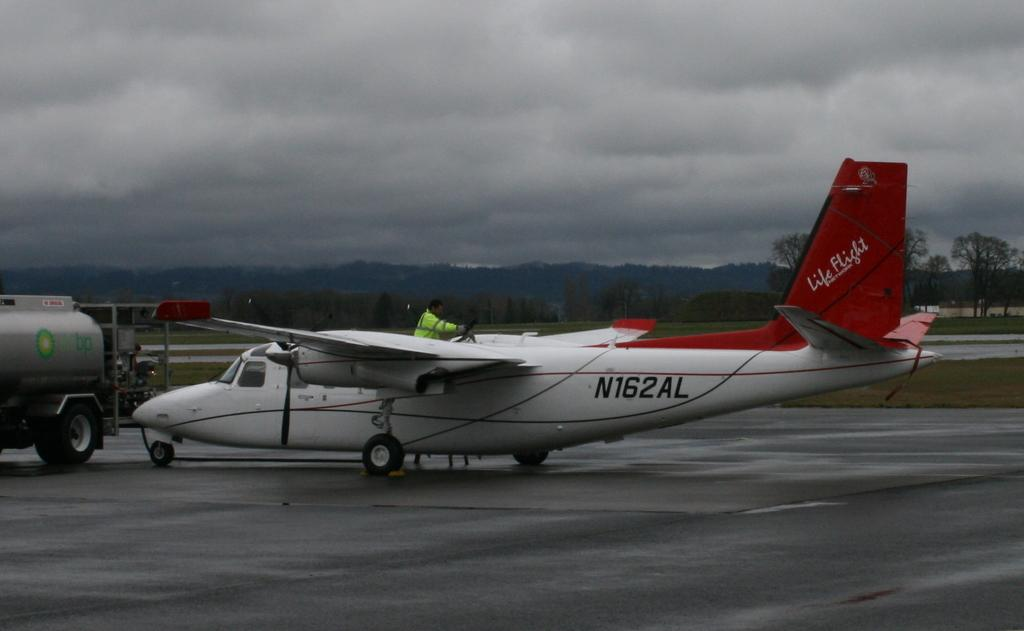Provide a one-sentence caption for the provided image. A Life Flight aircraft sits on a wet runway under a cloudy sky. 